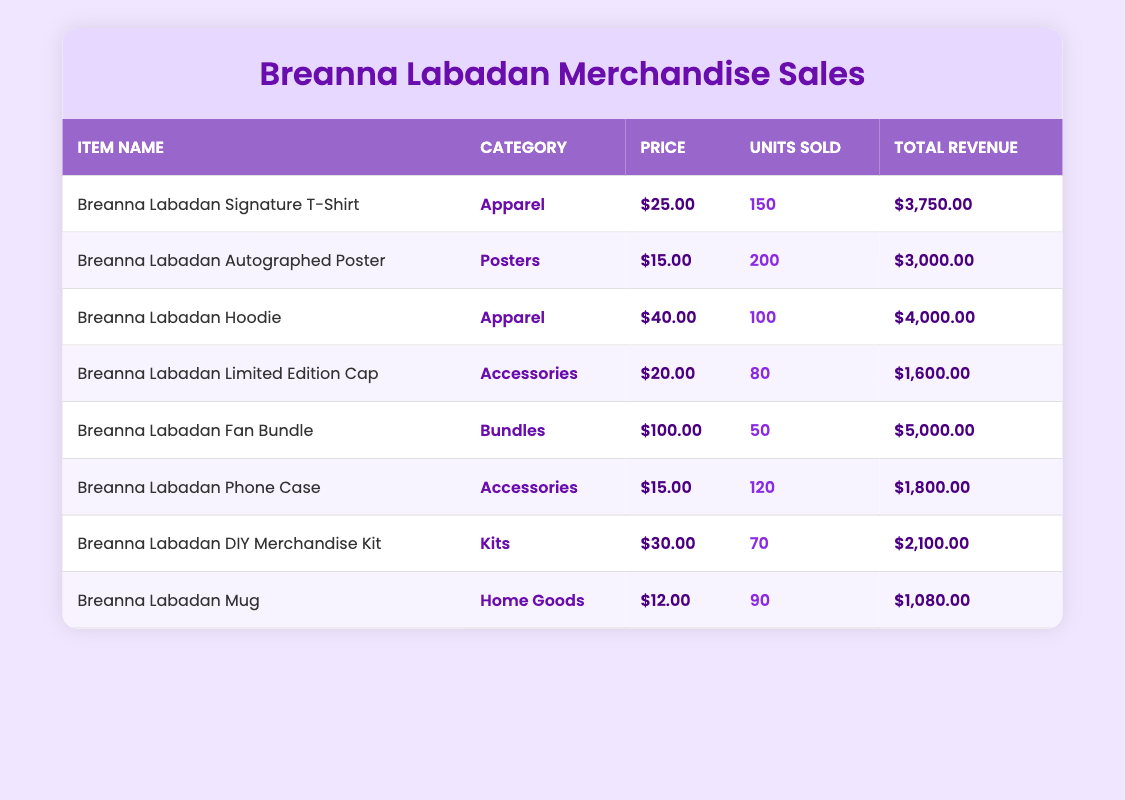What is the total revenue from the Breanna Labadan Signature T-Shirt? The total revenue is listed directly in the table for each item. For the Breanna Labadan Signature T-Shirt, the total revenue is $3,750.00.
Answer: $3,750.00 Which item sold the most units? By looking at the units sold for each item in the table, the Breanna Labadan Autographed Poster sold the most units at 200.
Answer: Breanna Labadan Autographed Poster What is the average price of all merchandise items? To calculate the average price, we need to sum the prices of all items: 25 + 15 + 40 + 20 + 100 + 15 + 30 + 12 =  252. Then, divide by the number of items (8): 252 / 8 = 31.5.
Answer: 31.50 Is it true that the Breanna Labadan Fan Bundle has the highest price? Comparing the price of the items in the table, the Breanna Labadan Fan Bundle has a price of $100, which is the highest among all items. Therefore, the statement is true.
Answer: Yes What is the total revenue from the Apparel category? The total revenue from the Apparel category can be found by summing the total revenues of items within that category. The revenues from the Breanna Labadan Signature T-Shirt ($3750.00) and the Hoodie ($4000.00) amounts to (3750 + 4000 = 7750).
Answer: $7,750.00 How many units of the Breanna Labadan Mug were sold compared to the Breanna Labadan Phone Case? The Breanna Labadan Mug had 90 units sold, while the Breanna Labadan Phone Case had 120 units sold. Therefore, more units were sold for the Phone Case than the Mug.
Answer: Phone Case sold more What category has the lowest total revenue? To find the category with the lowest total revenue, we calculate the total revenue for each category: Apparel (7750), Posters (3000), Accessories (1800 + 1600 = 3400), Bundles (5000), Kits (2100), and Home Goods (1080). The lowest revenue is from Home Goods at $1,080.00.
Answer: Home Goods What is the total number of units sold across all merchandise items? The total number of units sold is found by adding all the units sold: 150 + 200 + 100 + 80 + 50 + 120 + 70 + 90 = 960.
Answer: 960 